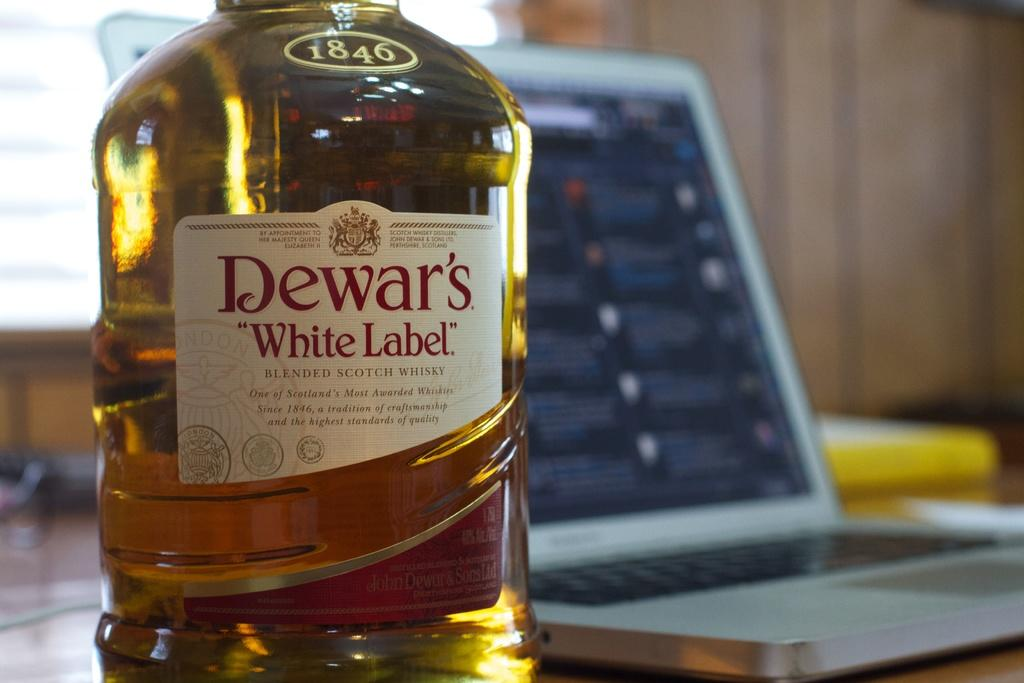<image>
Give a short and clear explanation of the subsequent image. A bottle of Dewar's White Label blended scotch whiskey. 